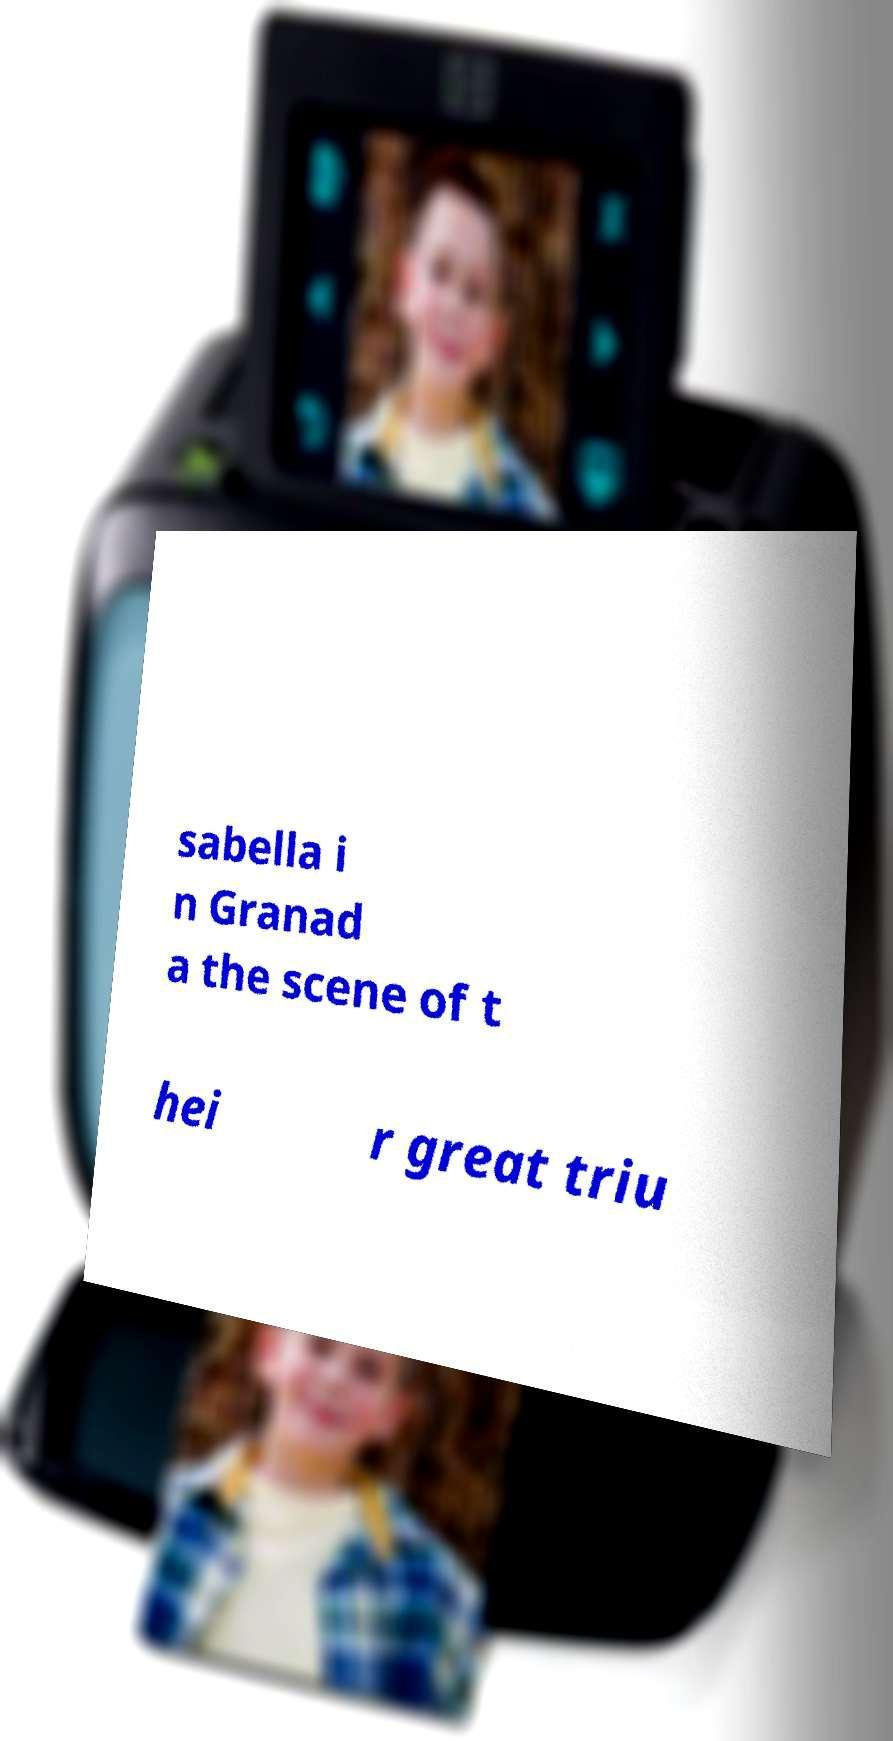Please identify and transcribe the text found in this image. sabella i n Granad a the scene of t hei r great triu 